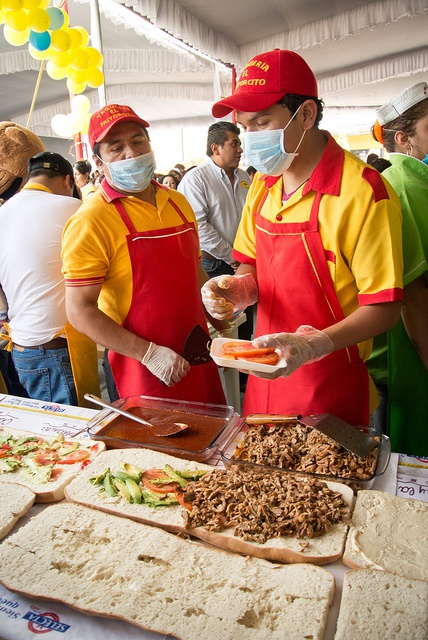Describe the objects in this image and their specific colors. I can see people in gold, maroon, red, brown, and olive tones, people in gold, brown, maroon, and orange tones, people in gold, lightgray, tan, black, and brown tones, people in gold, black, darkgreen, and lightgray tones, and people in gold, darkgray, lightgray, and gray tones in this image. 